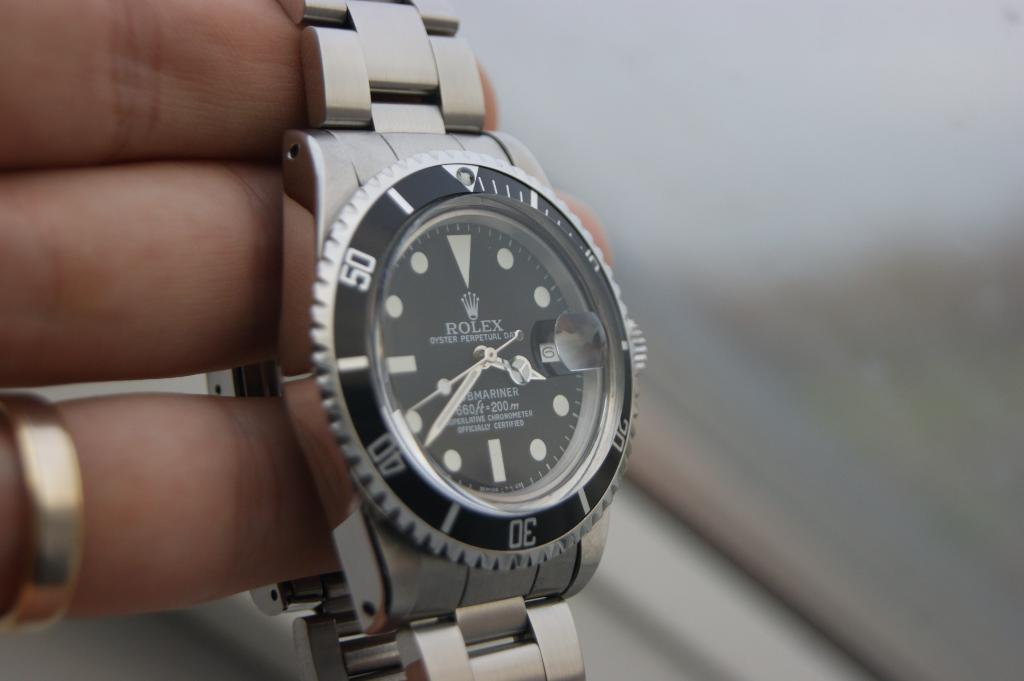<image>
Give a short and clear explanation of the subsequent image. hand holding a silver rolex submariner watch at time of 3:37 